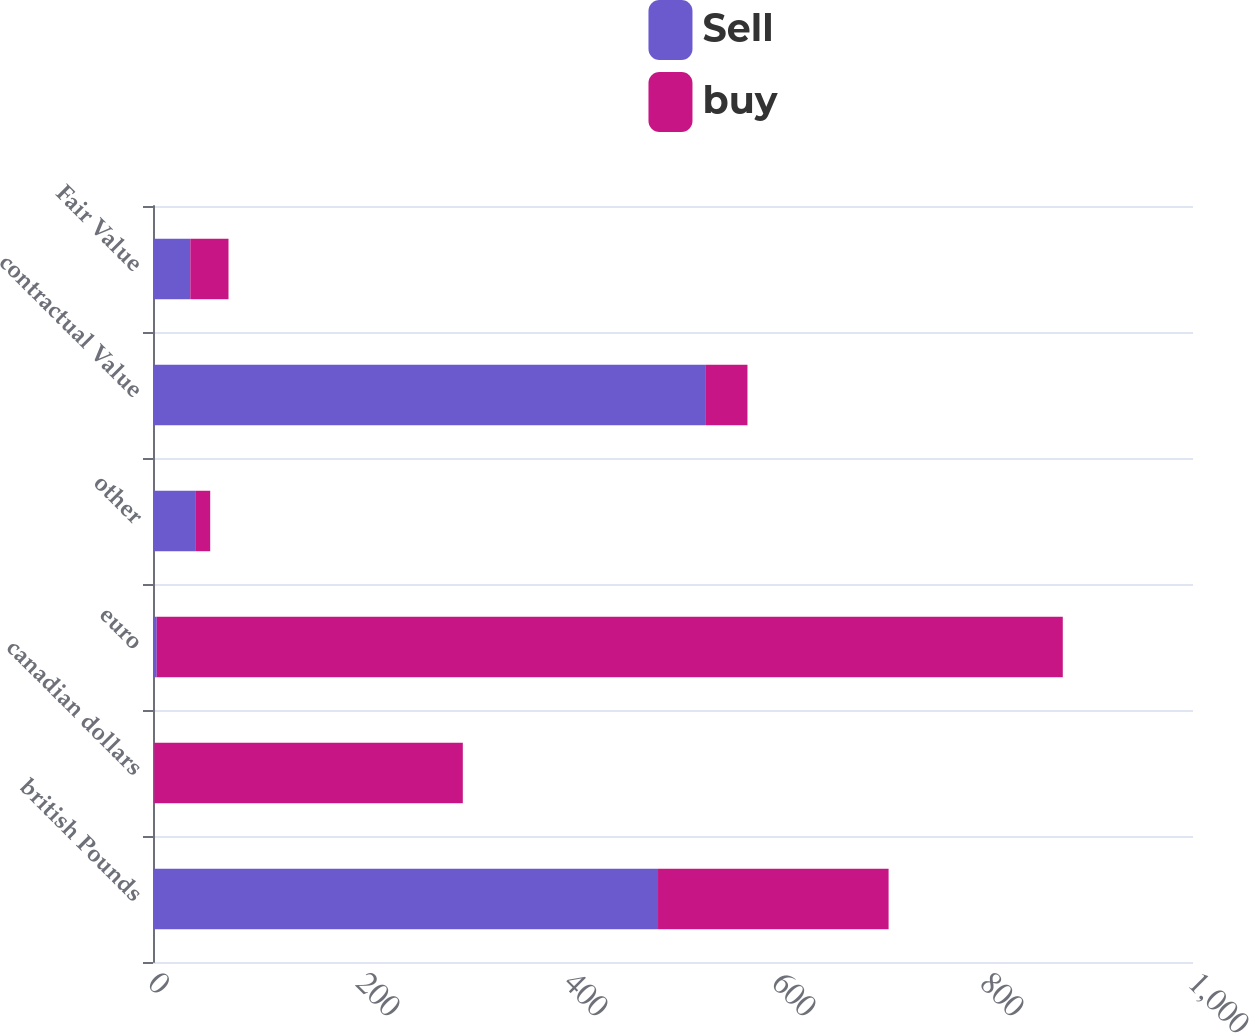Convert chart to OTSL. <chart><loc_0><loc_0><loc_500><loc_500><stacked_bar_chart><ecel><fcel>british Pounds<fcel>canadian dollars<fcel>euro<fcel>other<fcel>contractual Value<fcel>Fair Value<nl><fcel>Sell<fcel>485.6<fcel>1.2<fcel>3.6<fcel>40.6<fcel>531<fcel>35.9<nl><fcel>buy<fcel>221.7<fcel>296.7<fcel>871.2<fcel>14.4<fcel>40.6<fcel>36.7<nl></chart> 